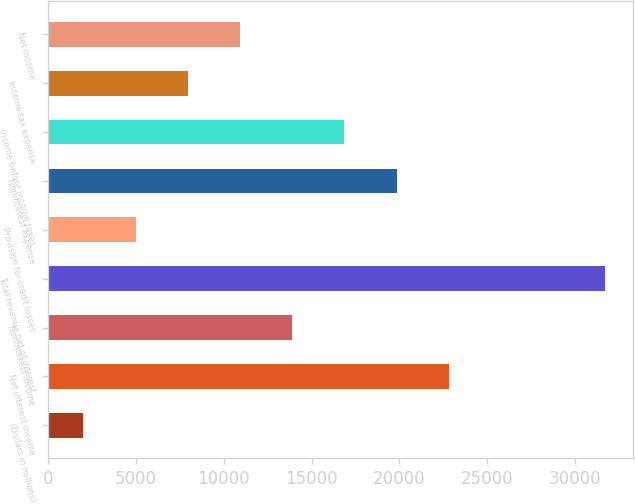Convert chart to OTSL. <chart><loc_0><loc_0><loc_500><loc_500><bar_chart><fcel>(Dollars in millions)<fcel>Net interest income<fcel>Noninterest income<fcel>Total revenue net of interest<fcel>Provision for credit losses<fcel>Noninterest expense<fcel>Income before income taxes<fcel>Income tax expense<fcel>Net income<nl><fcel>2016<fcel>22816.5<fcel>13902<fcel>31731<fcel>4987.5<fcel>19845<fcel>16873.5<fcel>7959<fcel>10930.5<nl></chart> 